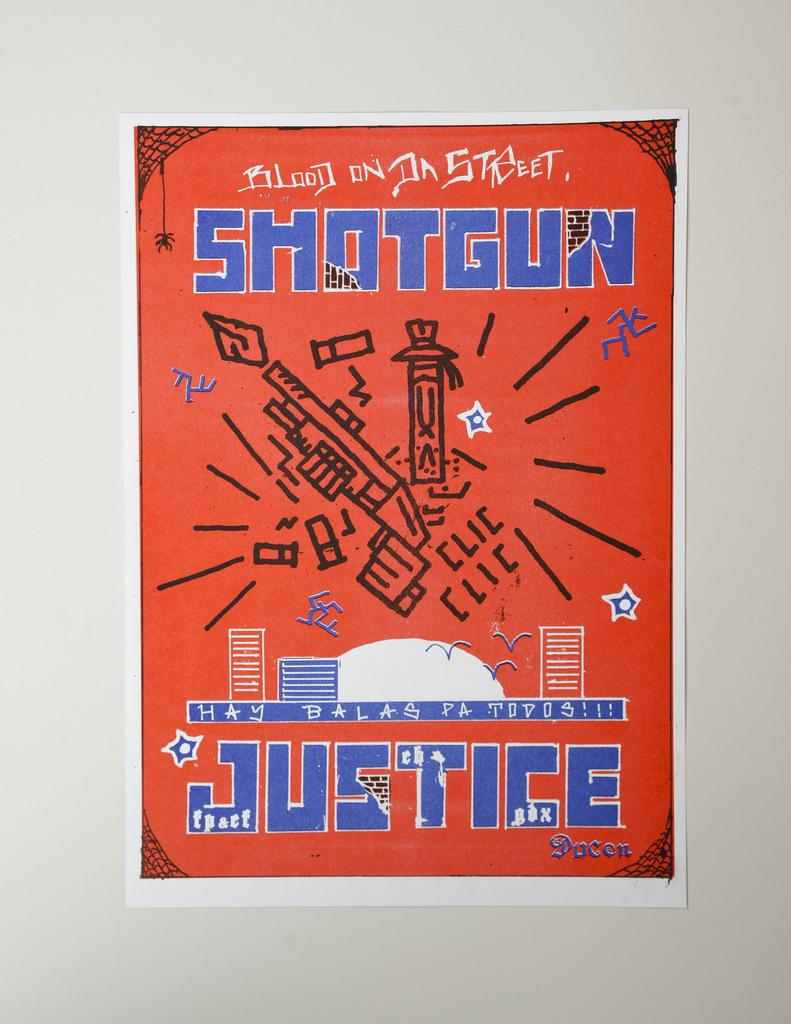<image>
Present a compact description of the photo's key features. an orange and blue sign that the word shotgun on it 